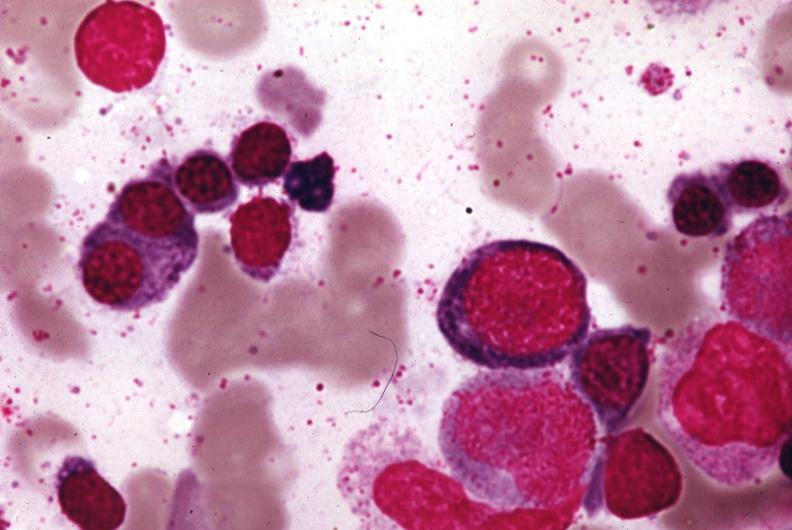does autoimmune thyroiditis show wrights stain?
Answer the question using a single word or phrase. No 